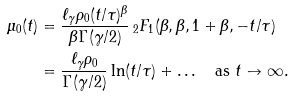Convert formula to latex. <formula><loc_0><loc_0><loc_500><loc_500>\mu _ { 0 } ( t ) & = \frac { \ell _ { \gamma } \rho _ { 0 } ( t / \tau ) ^ { \beta } } { \beta \Gamma ( \gamma / 2 ) } \, _ { 2 } F _ { 1 } ( \beta , \beta , 1 + \beta , - t / \tau ) \\ & = \frac { \ell _ { \gamma } \rho _ { 0 } } { \Gamma ( \gamma / 2 ) } \ln ( t / \tau ) + \dots \quad \text {as } t \to \infty .</formula> 